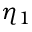<formula> <loc_0><loc_0><loc_500><loc_500>\eta _ { 1 }</formula> 